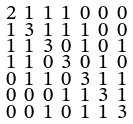<formula> <loc_0><loc_0><loc_500><loc_500>\begin{smallmatrix} 2 & 1 & 1 & 1 & 0 & 0 & 0 \\ 1 & 3 & 1 & 1 & 1 & 0 & 0 \\ 1 & 1 & 3 & 0 & 1 & 0 & 1 \\ 1 & 1 & 0 & 3 & 0 & 1 & 0 \\ 0 & 1 & 1 & 0 & 3 & 1 & 1 \\ 0 & 0 & 0 & 1 & 1 & 3 & 1 \\ 0 & 0 & 1 & 0 & 1 & 1 & 3 \end{smallmatrix}</formula> 